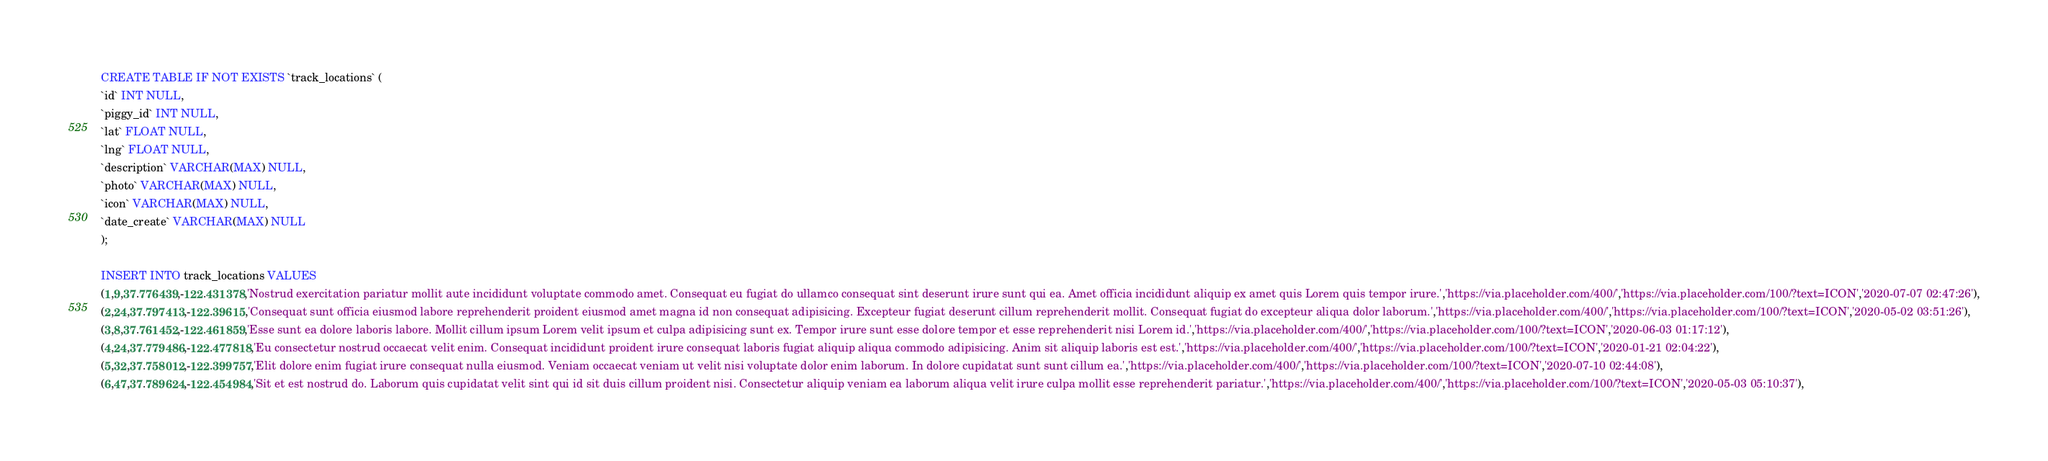<code> <loc_0><loc_0><loc_500><loc_500><_SQL_>CREATE TABLE IF NOT EXISTS `track_locations` (
`id` INT NULL,
`piggy_id` INT NULL,
`lat` FLOAT NULL,
`lng` FLOAT NULL,
`description` VARCHAR(MAX) NULL,
`photo` VARCHAR(MAX) NULL,
`icon` VARCHAR(MAX) NULL,
`date_create` VARCHAR(MAX) NULL
);

INSERT INTO track_locations VALUES
(1,9,37.776439,-122.431378,'Nostrud exercitation pariatur mollit aute incididunt voluptate commodo amet. Consequat eu fugiat do ullamco consequat sint deserunt irure sunt qui ea. Amet officia incididunt aliquip ex amet quis Lorem quis tempor irure.','https://via.placeholder.com/400/','https://via.placeholder.com/100/?text=ICON','2020-07-07 02:47:26'),
(2,24,37.797413,-122.39615,'Consequat sunt officia eiusmod labore reprehenderit proident eiusmod amet magna id non consequat adipisicing. Excepteur fugiat deserunt cillum reprehenderit mollit. Consequat fugiat do excepteur aliqua dolor laborum.','https://via.placeholder.com/400/','https://via.placeholder.com/100/?text=ICON','2020-05-02 03:51:26'),
(3,8,37.761452,-122.461859,'Esse sunt ea dolore laboris labore. Mollit cillum ipsum Lorem velit ipsum et culpa adipisicing sunt ex. Tempor irure sunt esse dolore tempor et esse reprehenderit nisi Lorem id.','https://via.placeholder.com/400/','https://via.placeholder.com/100/?text=ICON','2020-06-03 01:17:12'),
(4,24,37.779486,-122.477818,'Eu consectetur nostrud occaecat velit enim. Consequat incididunt proident irure consequat laboris fugiat aliquip aliqua commodo adipisicing. Anim sit aliquip laboris est est.','https://via.placeholder.com/400/','https://via.placeholder.com/100/?text=ICON','2020-01-21 02:04:22'),
(5,32,37.758012,-122.399757,'Elit dolore enim fugiat irure consequat nulla eiusmod. Veniam occaecat veniam ut velit nisi voluptate dolor enim laborum. In dolore cupidatat sunt sunt cillum ea.','https://via.placeholder.com/400/','https://via.placeholder.com/100/?text=ICON','2020-07-10 02:44:08'),
(6,47,37.789624,-122.454984,'Sit et est nostrud do. Laborum quis cupidatat velit sint qui id sit duis cillum proident nisi. Consectetur aliquip veniam ea laborum aliqua velit irure culpa mollit esse reprehenderit pariatur.','https://via.placeholder.com/400/','https://via.placeholder.com/100/?text=ICON','2020-05-03 05:10:37'),</code> 